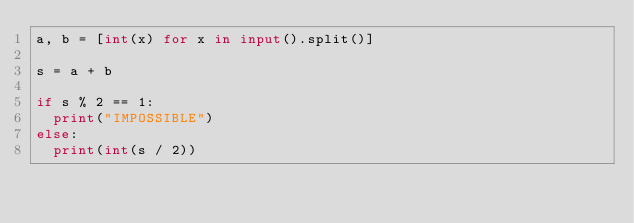<code> <loc_0><loc_0><loc_500><loc_500><_Python_>a, b = [int(x) for x in input().split()]

s = a + b

if s % 2 == 1:
  print("IMPOSSIBLE")
else:
  print(int(s / 2))
</code> 